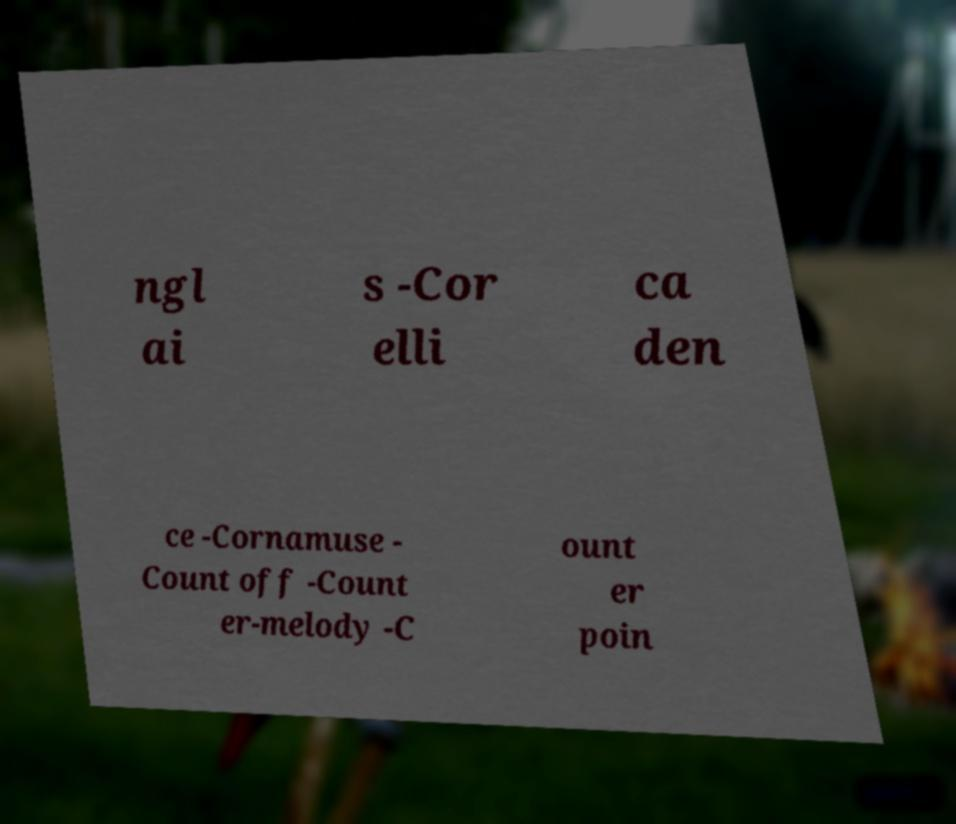There's text embedded in this image that I need extracted. Can you transcribe it verbatim? ngl ai s -Cor elli ca den ce -Cornamuse - Count off -Count er-melody -C ount er poin 